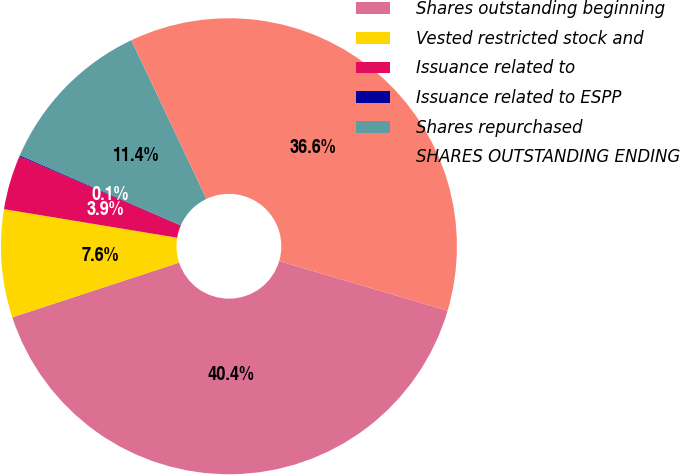<chart> <loc_0><loc_0><loc_500><loc_500><pie_chart><fcel>Shares outstanding beginning<fcel>Vested restricted stock and<fcel>Issuance related to<fcel>Issuance related to ESPP<fcel>Shares repurchased<fcel>SHARES OUTSTANDING ENDING<nl><fcel>40.39%<fcel>7.65%<fcel>3.86%<fcel>0.07%<fcel>11.43%<fcel>36.6%<nl></chart> 